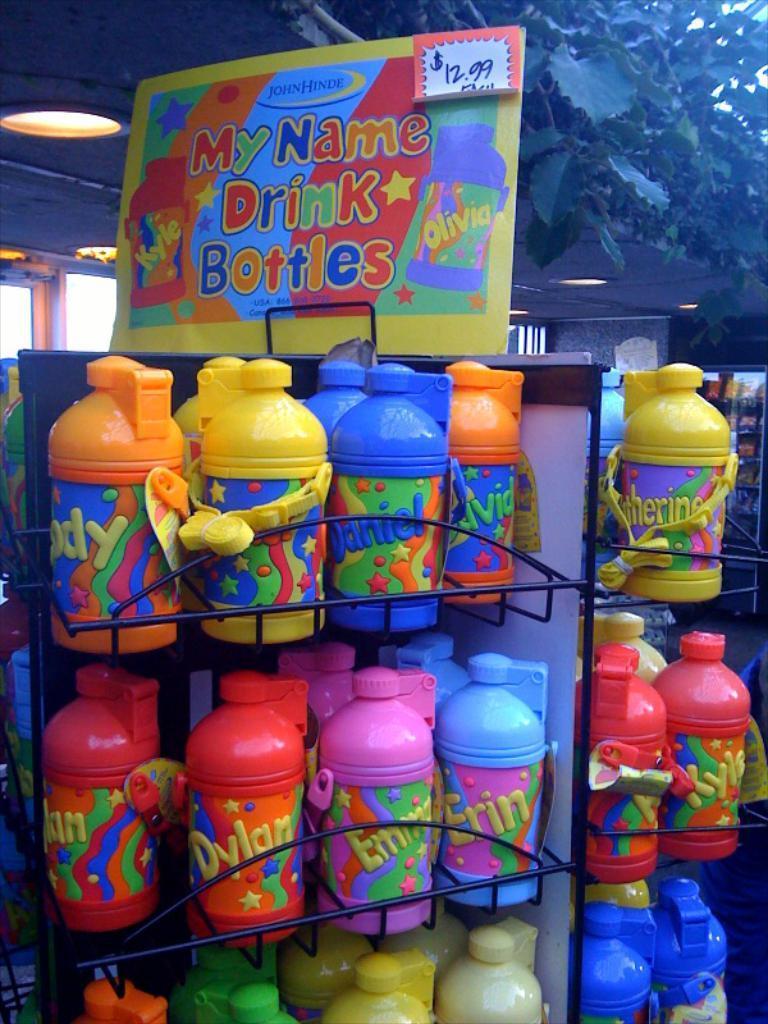Could you give a brief overview of what you see in this image? In this picture i could see different color water bottles they are in orange yellow blue red pink green. They have lid on them attached to the water bottle it self and there is tag. They are on the shelves arranged and there is a banner named for the water bottles and a rate plate. In the back ground i could see a small plant and a ceiling with a lights. 